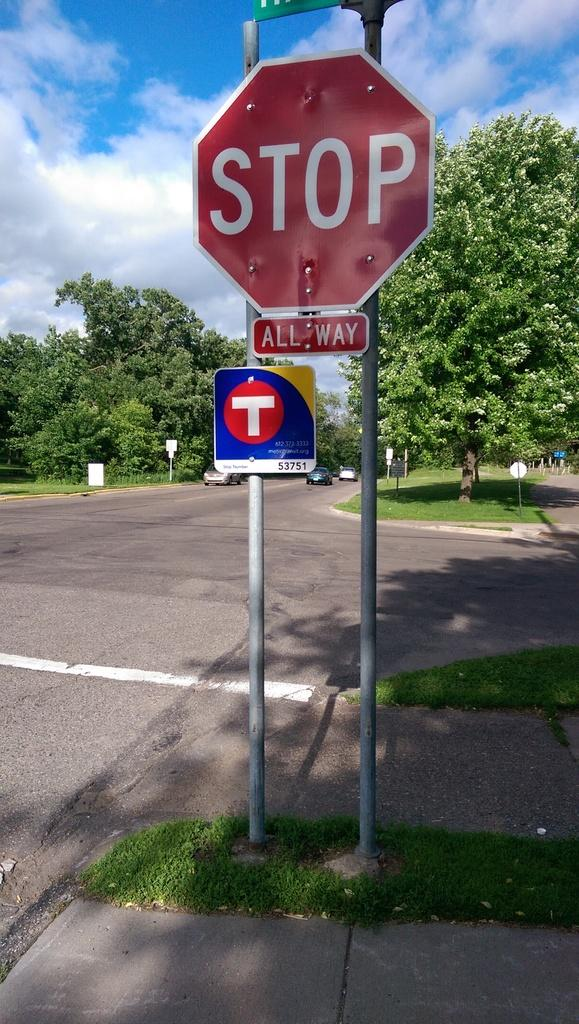<image>
Relay a brief, clear account of the picture shown. All way is written under the stop sign to alert drivers that every direction must stop before proceeding. 